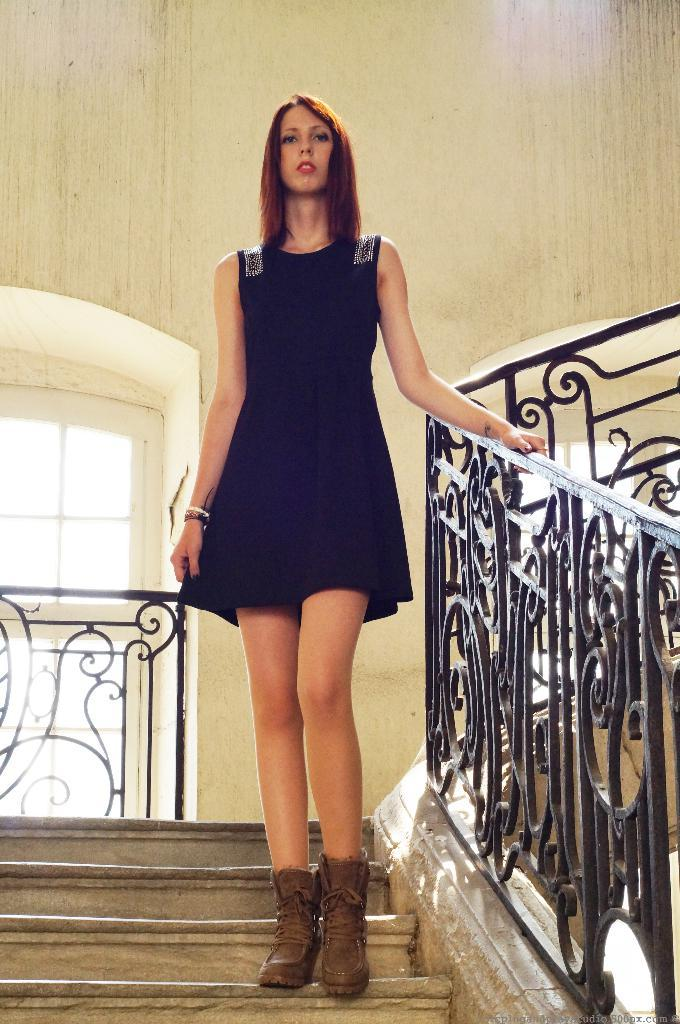Who is the main subject in the image? There is a woman in the image. What is the woman doing in the image? The woman is standing on the stairs. What is the woman wearing in the image? The woman is wearing a black dress. What can be seen on the right side of the image? There is a grilled fence on the right side of the image. What type of jar is the woman holding in her thought in the image? There is no jar or reference to thoughts in the image; it only shows a woman standing on the stairs wearing a black dress, with a grilled fence on the right side. 